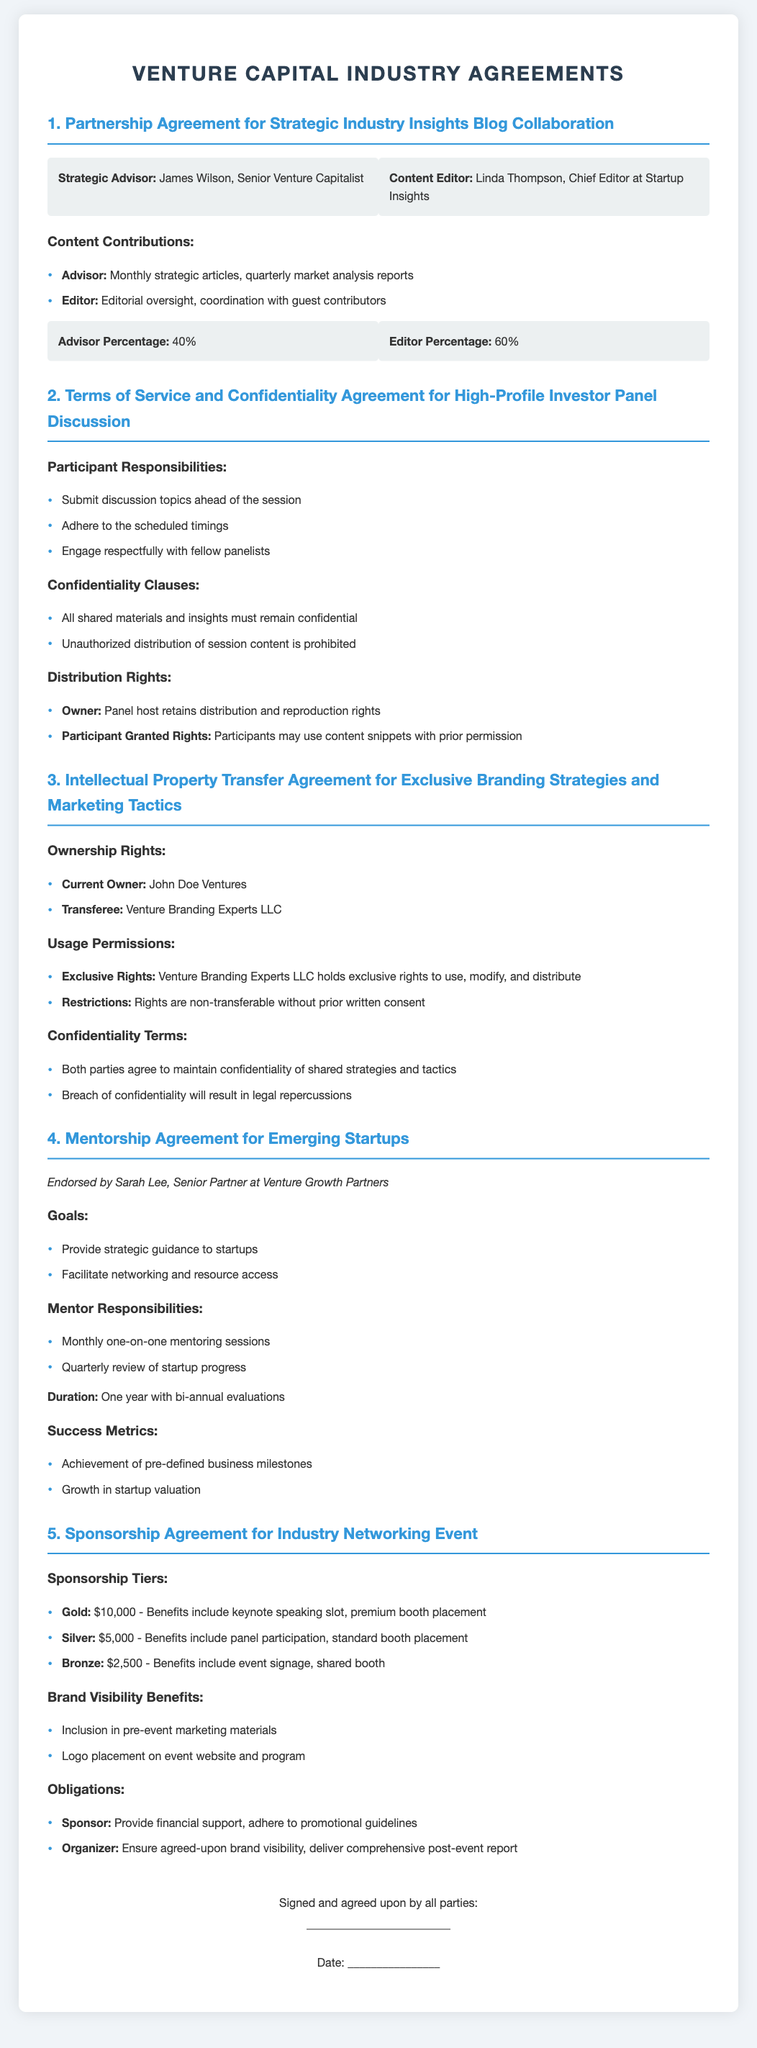What is the role of the Strategic Advisor? The role of the Strategic Advisor is detailed in the document and is assigned to James Wilson, who is a Senior Venture Capitalist.
Answer: James Wilson, Senior Venture Capitalist What percentage of profits does the Editor receive? The profit-sharing structure specifies the Editor's percentage in the document, which is provided alongside the Advisor's percentage.
Answer: 60% Who endorses the Mentorship Agreement? The document includes an endorsement which identifies the key supportive individual for the Mentorship Agreement.
Answer: Sarah Lee What is the duration of the Mentorship Agreement? The duration of the Mentorship Agreement is explicitly mentioned in the document, indicating how long the agreement will last before evaluations.
Answer: One year What is the financial contribution for the Gold sponsorship tier? The document outlines different sponsorship tiers with their respective financial contributions, specifically noting the amount for Gold.
Answer: $10,000 What is required from participants according to the Terms of Service? The document outlines specific responsibilities that participants must adhere to, which include several tasks expected from them.
Answer: Submit discussion topics ahead of the session What rights does the Panel host retain? The document specifies the distribution rights owned by the Panel host in relation to session content and materials.
Answer: Distribution and reproduction rights What type of rights are granted to Venture Branding Experts LLC? The document outlines the terms related to ownership rights and permissions for the transferee of the Intellectual Property Transfer Agreement.
Answer: Exclusive rights What is included in the Sponsorship Agreement's brand visibility benefits? The document mentions certain benefits that sponsors receive, specifically in terms of visibility related to the event.
Answer: Inclusion in pre-event marketing materials 